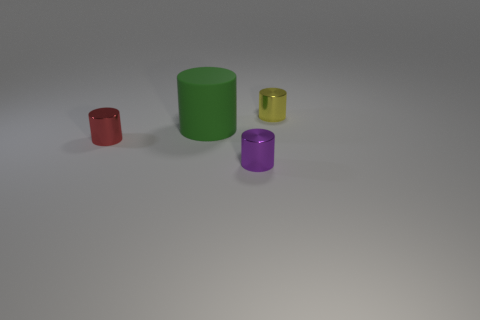Is there anything else that is made of the same material as the green cylinder?
Your answer should be compact. No. How many tiny things are purple metal balls or metallic cylinders?
Provide a succinct answer. 3. Are there any purple things that have the same material as the big green cylinder?
Provide a succinct answer. No. What material is the tiny object on the right side of the tiny purple object?
Provide a succinct answer. Metal. There is a metal cylinder that is left of the large cylinder; is its color the same as the object that is behind the rubber thing?
Your response must be concise. No. How many other objects are there of the same shape as the large green rubber object?
Ensure brevity in your answer.  3. There is a metallic cylinder that is in front of the small red object; how big is it?
Make the answer very short. Small. There is a metallic object behind the big cylinder; how many purple cylinders are behind it?
Give a very brief answer. 0. How many other objects are there of the same size as the matte object?
Ensure brevity in your answer.  0. There is a small metal thing behind the red metal cylinder; is its shape the same as the tiny purple thing?
Ensure brevity in your answer.  Yes. 